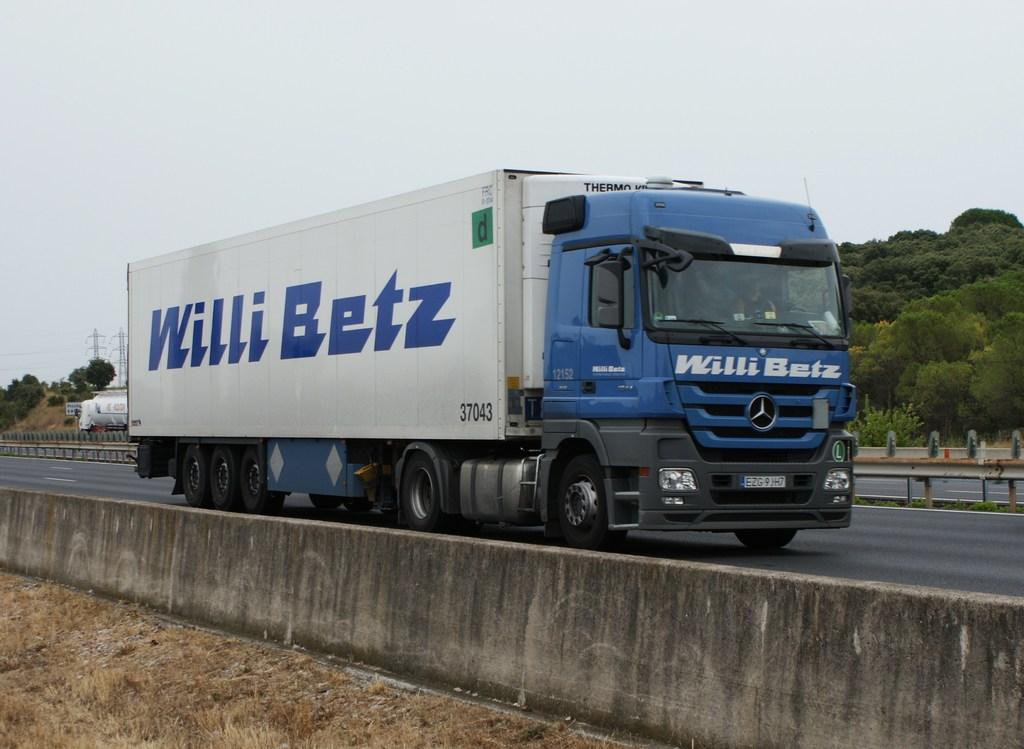What is the main subject in the center of the image? There is a vehicle in the center of the image. What is located at the bottom of the image? There is a road and grass at the bottom of the image. What can be seen in the background of the image? There are trees in the background of the image. What is visible at the top of the image? The sky is visible at the top of the image. How many toes are visible on the vehicle in the image? There are no toes present in the image, as it features a vehicle and not a person or animal. 